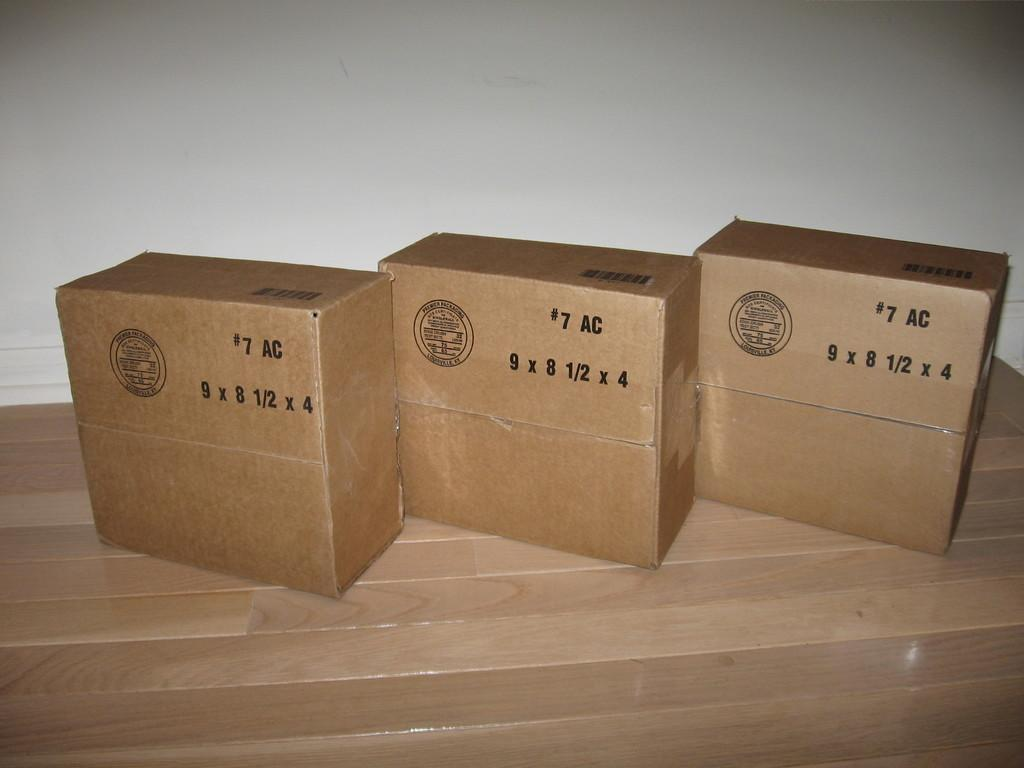<image>
Write a terse but informative summary of the picture. Three #7 AC 9 x 8 1/2 x 4 corrugated cardboard shipping boxes sitting next to each other. 